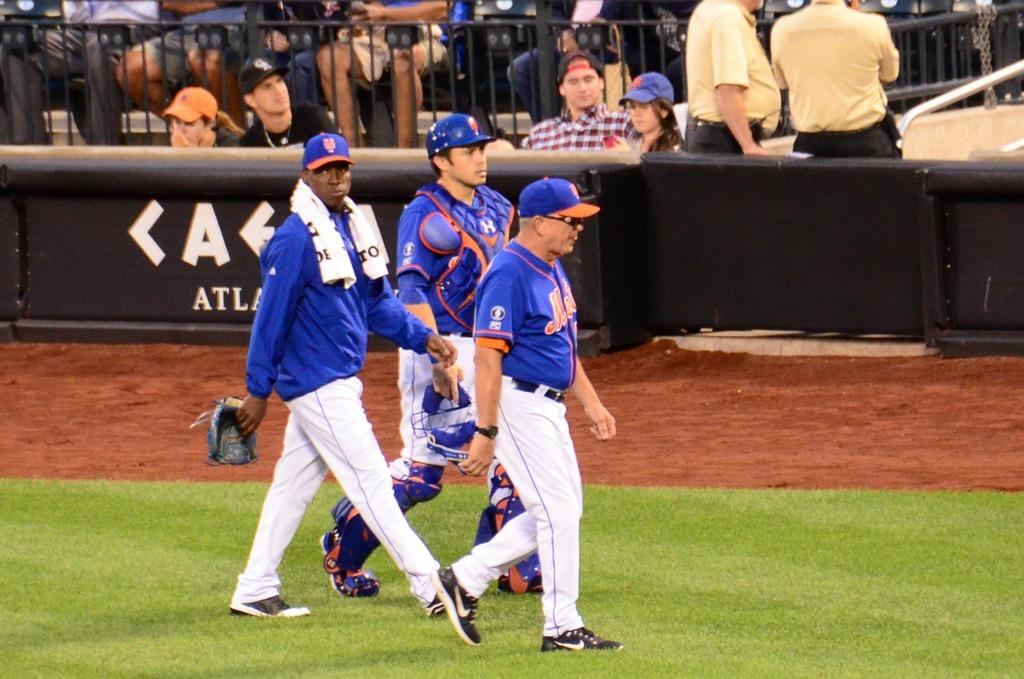<image>
Provide a brief description of the given image. Mets players and an official cross the grassy baseball field. 